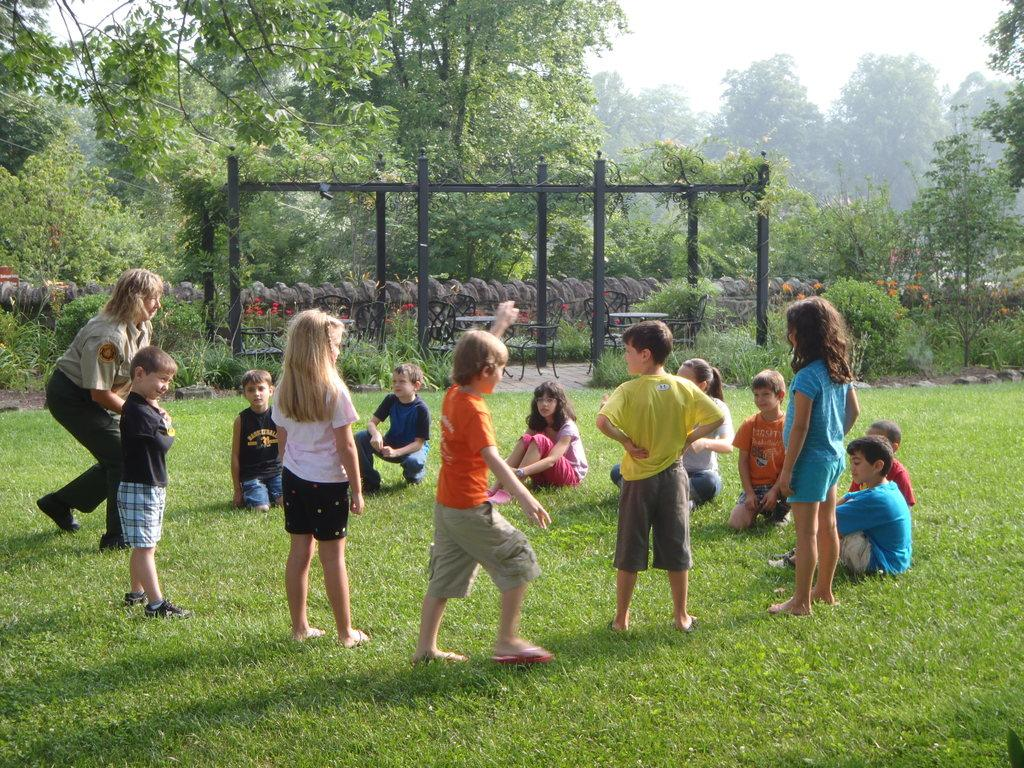What are the children in the image doing? There is a group of children playing in the image. What is the woman on the left side of the image doing? The woman is running on the left side of the image. What can be seen in the background of the image? There are trees visible in the background of the image. What is visible at the top of the image? The sky is visible at the top of the image. What type of suit is the woman wearing in the image? There is no suit present in the image; the woman is running in regular clothing. Where are the children and woman going on vacation in the image? There is no indication of a vacation in the image; it simply shows a group of children playing and a woman running. 